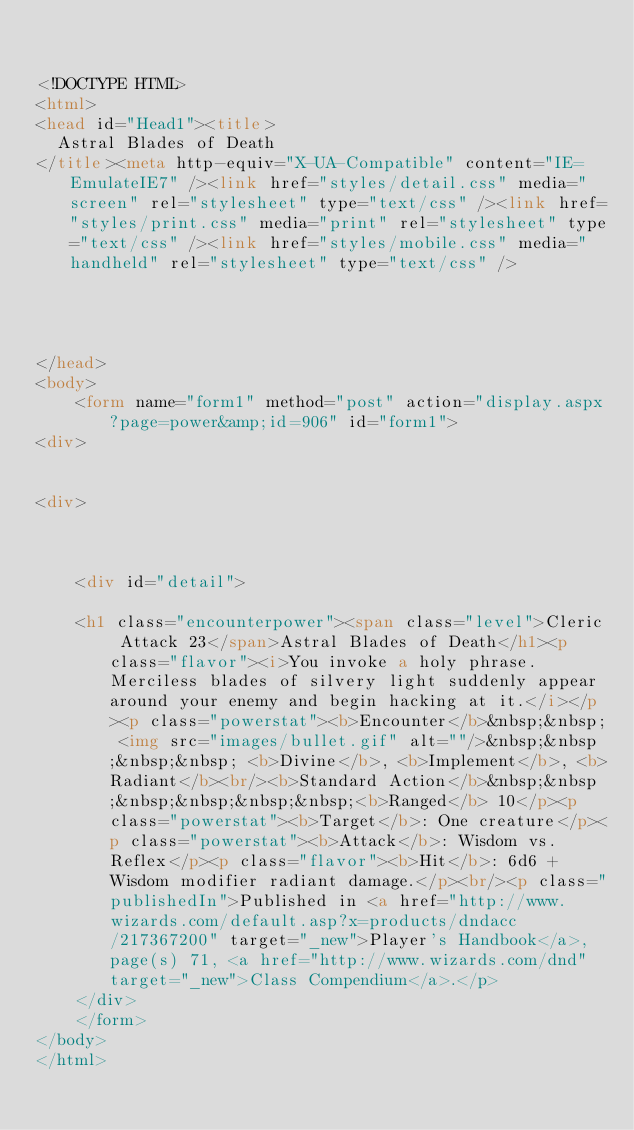<code> <loc_0><loc_0><loc_500><loc_500><_HTML_>

<!DOCTYPE HTML>
<html>
<head id="Head1"><title>
	Astral Blades of Death
</title><meta http-equiv="X-UA-Compatible" content="IE=EmulateIE7" /><link href="styles/detail.css" media="screen" rel="stylesheet" type="text/css" /><link href="styles/print.css" media="print" rel="stylesheet" type="text/css" /><link href="styles/mobile.css" media="handheld" rel="stylesheet" type="text/css" />
    
    
    

</head>
<body>
    <form name="form1" method="post" action="display.aspx?page=power&amp;id=906" id="form1">
<div>


<div>

	
	
    <div id="detail">
		
		<h1 class="encounterpower"><span class="level">Cleric Attack 23</span>Astral Blades of Death</h1><p class="flavor"><i>You invoke a holy phrase. Merciless blades of silvery light suddenly appear around your enemy and begin hacking at it.</i></p><p class="powerstat"><b>Encounter</b>&nbsp;&nbsp; <img src="images/bullet.gif" alt=""/>&nbsp;&nbsp;&nbsp;&nbsp; <b>Divine</b>, <b>Implement</b>, <b>Radiant</b><br/><b>Standard Action</b>&nbsp;&nbsp;&nbsp;&nbsp;&nbsp;&nbsp;<b>Ranged</b> 10</p><p class="powerstat"><b>Target</b>: One creature</p><p class="powerstat"><b>Attack</b>: Wisdom vs. Reflex</p><p class="flavor"><b>Hit</b>: 6d6 + Wisdom modifier radiant damage.</p><br/><p class="publishedIn">Published in <a href="http://www.wizards.com/default.asp?x=products/dndacc/217367200" target="_new">Player's Handbook</a>, page(s) 71, <a href="http://www.wizards.com/dnd" target="_new">Class Compendium</a>.</p>
    </div>
    </form>
</body>
</html>


</code> 